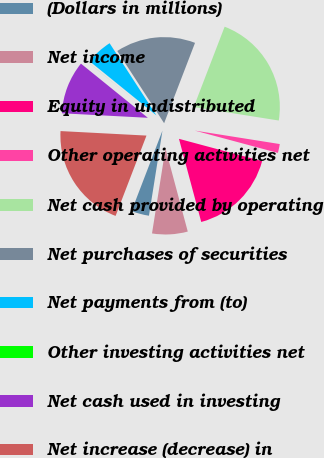Convert chart. <chart><loc_0><loc_0><loc_500><loc_500><pie_chart><fcel>(Dollars in millions)<fcel>Net income<fcel>Equity in undistributed<fcel>Other operating activities net<fcel>Net cash provided by operating<fcel>Net purchases of securities<fcel>Net payments from (to)<fcel>Other investing activities net<fcel>Net cash used in investing<fcel>Net increase (decrease) in<nl><fcel>3.34%<fcel>6.67%<fcel>16.66%<fcel>1.67%<fcel>21.66%<fcel>15.0%<fcel>5.0%<fcel>0.01%<fcel>10.0%<fcel>19.99%<nl></chart> 